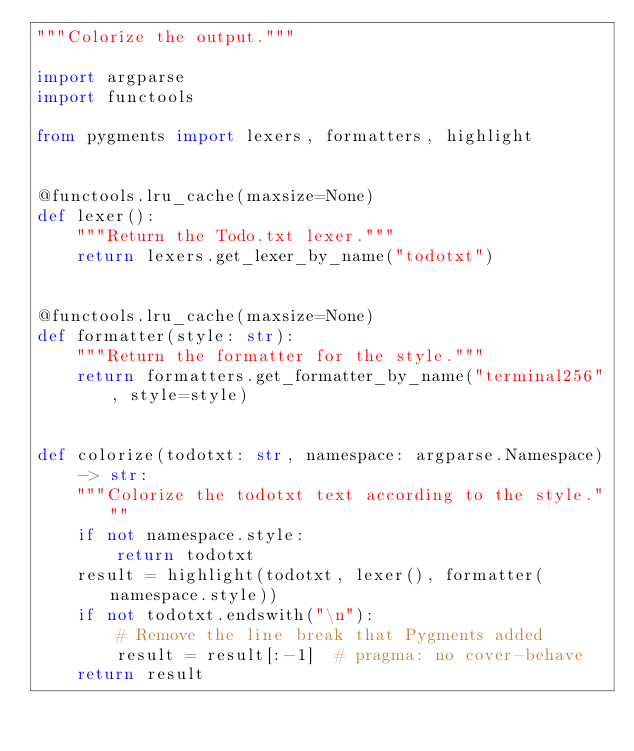Convert code to text. <code><loc_0><loc_0><loc_500><loc_500><_Python_>"""Colorize the output."""

import argparse
import functools

from pygments import lexers, formatters, highlight


@functools.lru_cache(maxsize=None)
def lexer():
    """Return the Todo.txt lexer."""
    return lexers.get_lexer_by_name("todotxt")


@functools.lru_cache(maxsize=None)
def formatter(style: str):
    """Return the formatter for the style."""
    return formatters.get_formatter_by_name("terminal256", style=style)


def colorize(todotxt: str, namespace: argparse.Namespace) -> str:
    """Colorize the todotxt text according to the style."""
    if not namespace.style:
        return todotxt
    result = highlight(todotxt, lexer(), formatter(namespace.style))
    if not todotxt.endswith("\n"):
        # Remove the line break that Pygments added
        result = result[:-1]  # pragma: no cover-behave
    return result
</code> 